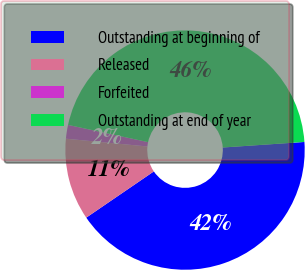Convert chart to OTSL. <chart><loc_0><loc_0><loc_500><loc_500><pie_chart><fcel>Outstanding at beginning of<fcel>Released<fcel>Forfeited<fcel>Outstanding at end of year<nl><fcel>41.53%<fcel>11.06%<fcel>1.86%<fcel>45.54%<nl></chart> 